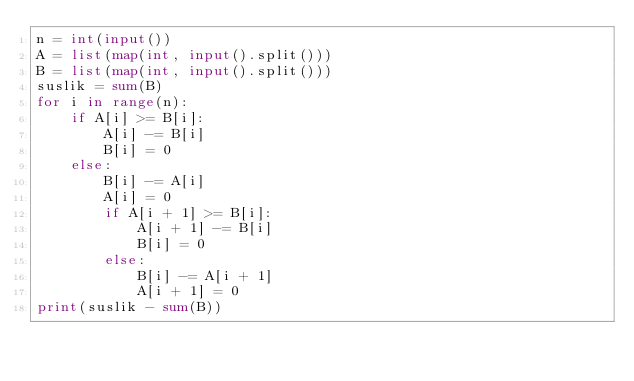Convert code to text. <code><loc_0><loc_0><loc_500><loc_500><_Python_>n = int(input())
A = list(map(int, input().split()))
B = list(map(int, input().split()))
suslik = sum(B)
for i in range(n):
    if A[i] >= B[i]:
        A[i] -= B[i]
        B[i] = 0
    else:
        B[i] -= A[i]
        A[i] = 0
        if A[i + 1] >= B[i]:
            A[i + 1] -= B[i]
            B[i] = 0
        else:
            B[i] -= A[i + 1]
            A[i + 1] = 0
print(suslik - sum(B))</code> 